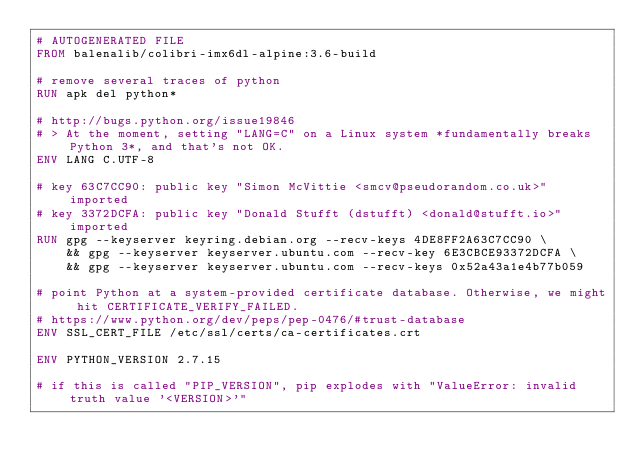Convert code to text. <code><loc_0><loc_0><loc_500><loc_500><_Dockerfile_># AUTOGENERATED FILE
FROM balenalib/colibri-imx6dl-alpine:3.6-build

# remove several traces of python
RUN apk del python*

# http://bugs.python.org/issue19846
# > At the moment, setting "LANG=C" on a Linux system *fundamentally breaks Python 3*, and that's not OK.
ENV LANG C.UTF-8

# key 63C7CC90: public key "Simon McVittie <smcv@pseudorandom.co.uk>" imported
# key 3372DCFA: public key "Donald Stufft (dstufft) <donald@stufft.io>" imported
RUN gpg --keyserver keyring.debian.org --recv-keys 4DE8FF2A63C7CC90 \
	&& gpg --keyserver keyserver.ubuntu.com --recv-key 6E3CBCE93372DCFA \
	&& gpg --keyserver keyserver.ubuntu.com --recv-keys 0x52a43a1e4b77b059

# point Python at a system-provided certificate database. Otherwise, we might hit CERTIFICATE_VERIFY_FAILED.
# https://www.python.org/dev/peps/pep-0476/#trust-database
ENV SSL_CERT_FILE /etc/ssl/certs/ca-certificates.crt

ENV PYTHON_VERSION 2.7.15

# if this is called "PIP_VERSION", pip explodes with "ValueError: invalid truth value '<VERSION>'"</code> 